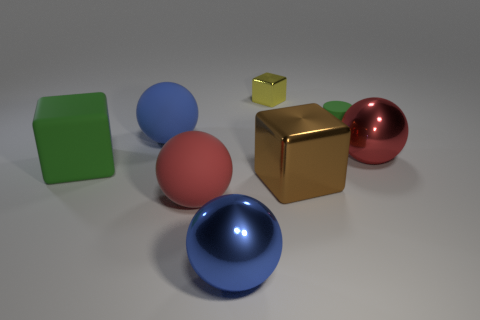Subtract 1 balls. How many balls are left? 3 Add 2 large red matte balls. How many objects exist? 10 Subtract all cubes. How many objects are left? 5 Subtract all cylinders. Subtract all matte objects. How many objects are left? 3 Add 7 tiny matte things. How many tiny matte things are left? 8 Add 3 large blue matte things. How many large blue matte things exist? 4 Subtract 0 purple cylinders. How many objects are left? 8 